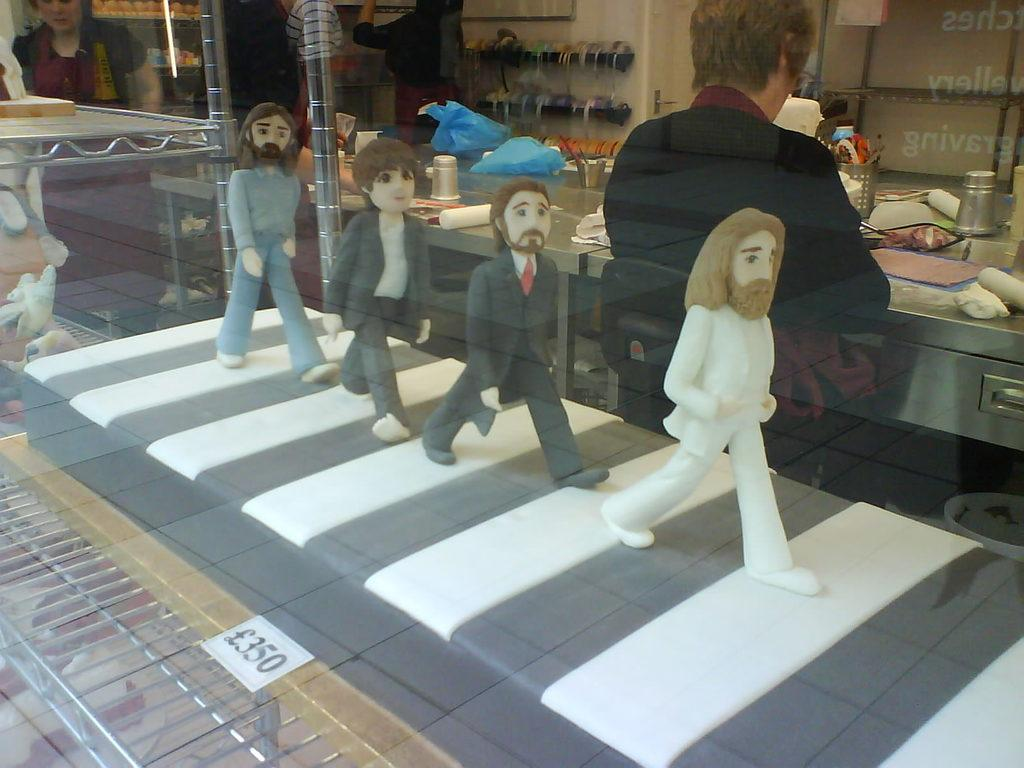What type of furniture can be seen in the image? There are tables in the image. Can you describe the people in the image? There are people in the image. What is located behind the tables? There is a wall in the image. What are the human statues doing in the image? The human statues are present in the image. How are the tables decorated? The tables have covers on them. What can be found on the tables along with the table covers? There are glasses on the tables. Are there any other objects on the tables besides glasses? Yes, there are additional objects on the tables. What type of trousers are the people wearing in the image? There is no information about the type of trousers the people are wearing in the image. Are there any stockings visible on the human statues in the image? There is no mention of stockings or any clothing on the human statues in the image. 